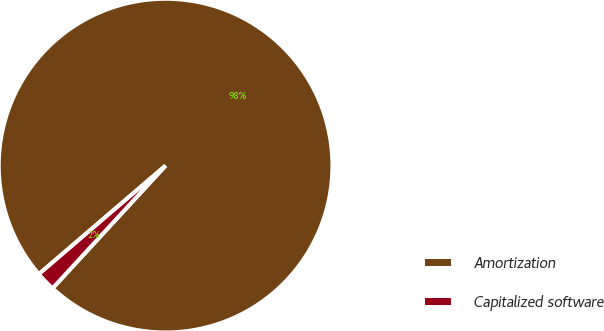Convert chart. <chart><loc_0><loc_0><loc_500><loc_500><pie_chart><fcel>Amortization<fcel>Capitalized software<nl><fcel>98.12%<fcel>1.88%<nl></chart> 